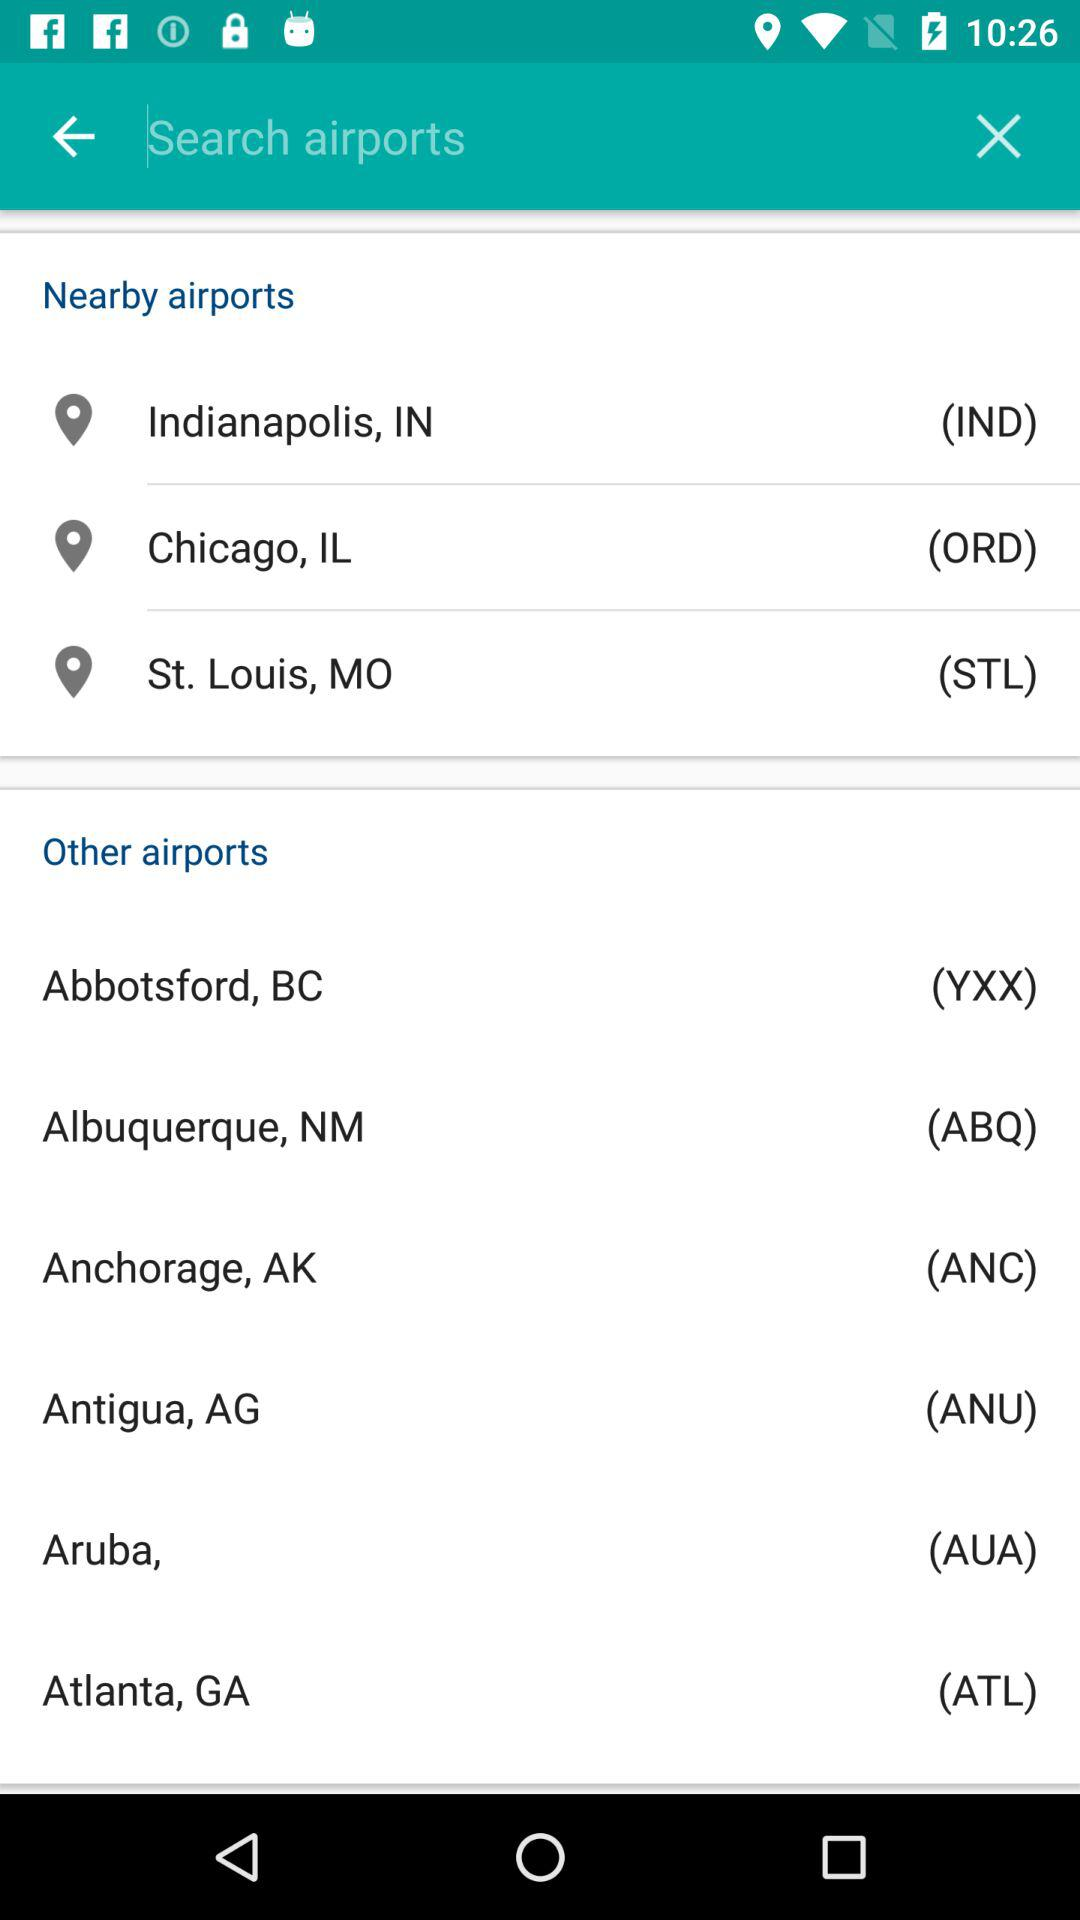What are the names of the other airports? The names of the other airports are "Abbotsford, BC", "Albuquerque, NM", "Anchorage, AK", "Antigua, AG", "Aruba," and "Atlanta, GA". 